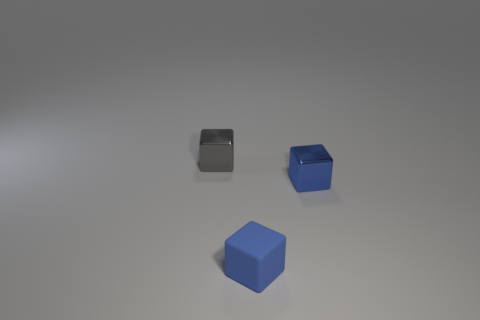Add 1 blue things. How many objects exist? 4 Subtract all blue cylinders. How many blue cubes are left? 2 Subtract all small metal blocks. How many blocks are left? 1 Subtract 1 cubes. How many cubes are left? 2 Subtract all purple blocks. Subtract all red spheres. How many blocks are left? 3 Add 1 blue rubber blocks. How many blue rubber blocks are left? 2 Add 1 small objects. How many small objects exist? 4 Subtract 0 cyan spheres. How many objects are left? 3 Subtract all tiny metal cubes. Subtract all big cyan matte blocks. How many objects are left? 1 